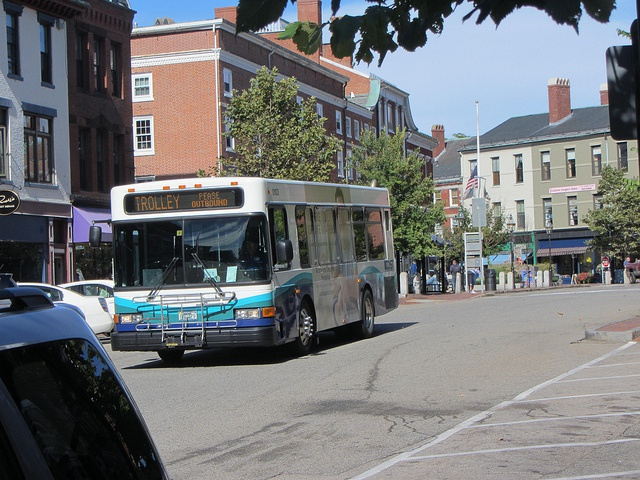Describe the objects in this image and their specific colors. I can see bus in gray, black, white, and darkgray tones, car in gray, black, darkblue, and blue tones, car in gray, lightgray, darkgray, and black tones, people in gray, darkgray, black, and darkblue tones, and car in gray, black, and darkgray tones in this image. 